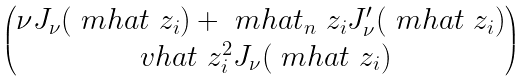Convert formula to latex. <formula><loc_0><loc_0><loc_500><loc_500>\begin{pmatrix} \nu J _ { \nu } ( \ m h a t \ z _ { i } ) + \ m h a t _ { n } \ z _ { i } J ^ { \prime } _ { \nu } ( \ m h a t \ z _ { i } ) \\ \ v h a t \ z _ { i } ^ { 2 } J _ { \nu } ( \ m h a t \ z _ { i } ) \end{pmatrix}</formula> 